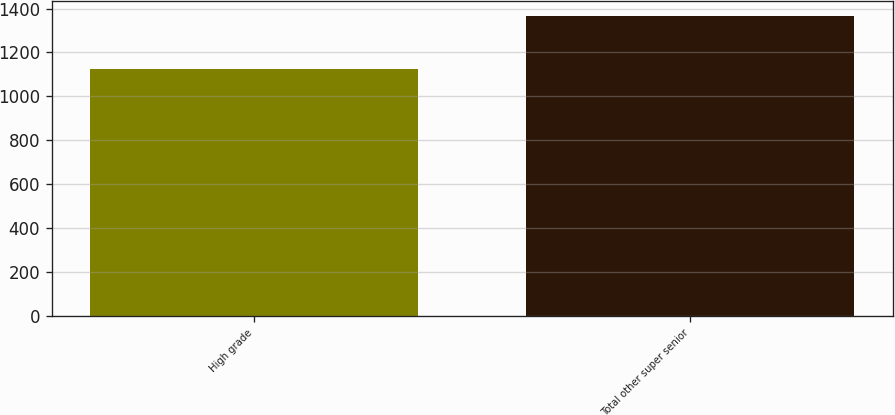Convert chart to OTSL. <chart><loc_0><loc_0><loc_500><loc_500><bar_chart><fcel>High grade<fcel>Total other super senior<nl><fcel>1127<fcel>1365<nl></chart> 